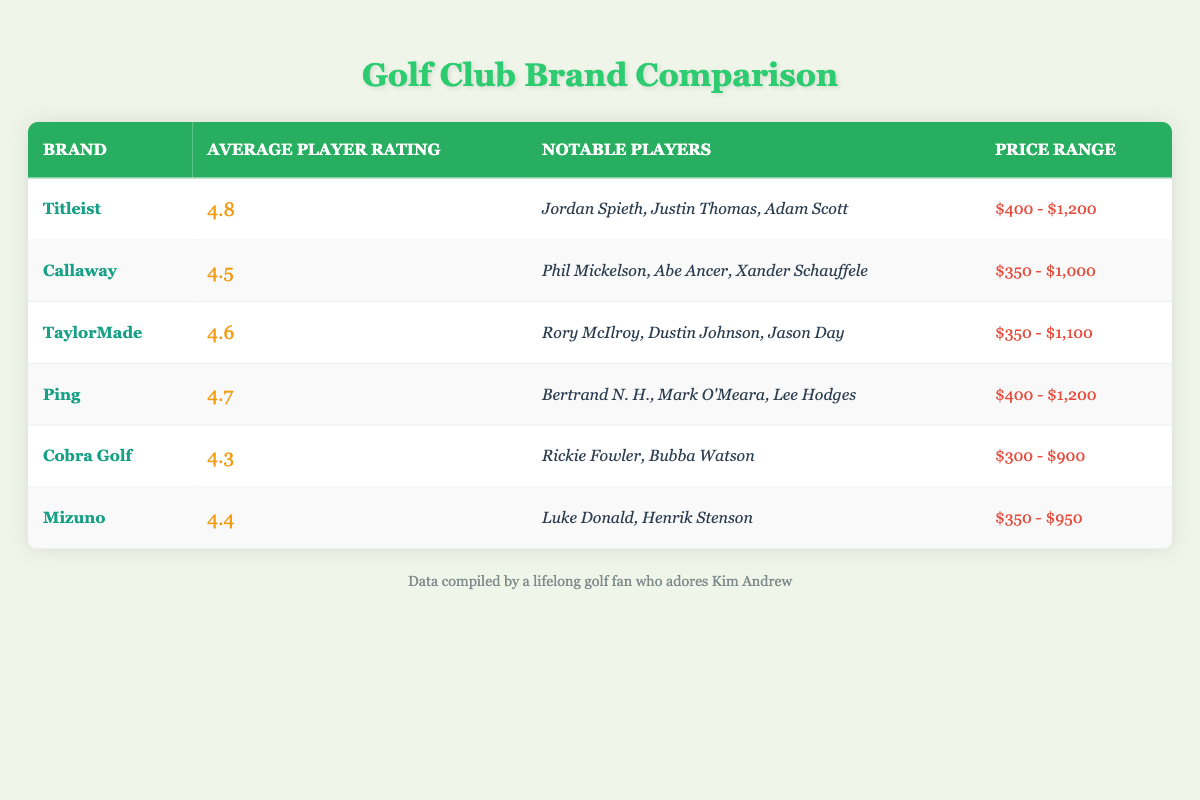What is the average player rating of Titleist? Titleist has an average player rating listed in the table. That rating is found in the row corresponding to Titleist, where it's mentioned clearly as 4.8.
Answer: 4.8 Which brand has the highest average player rating? By comparing the average player ratings listed for each brand, Titleist has the highest rating at 4.8, followed by Ping at 4.7.
Answer: Titleist Is the price range for Callaway clubs lower than that for Cobra Golf clubs? The price range for Callaway is from $350 to $1,000, while for Cobra Golf it's $300 to $900. Since $1,000 is higher than $900, the price range for Callaway is not lower than Cobra Golf's range.
Answer: No How many notable players are associated with TaylorMade? Looking at the row for TaylorMade, it lists three notable players: Rory McIlroy, Dustin Johnson, and Jason Day. Therefore, the count of notable players is three.
Answer: 3 What is the difference in average player ratings between Ping and Mizuno? The average player rating for Ping is 4.7, and for Mizuno, it is 4.4. To find the difference, subtract Mizuno's rating from Ping's: 4.7 - 4.4 = 0.3.
Answer: 0.3 Are there more notable players listed for Cobra Golf than for Mizuno? The notable players for Cobra Golf are Rickie Fowler and Bubba Watson, totaling two. For Mizuno, there are also two notable players: Luke Donald and Henrik Stenson. Since both brands have the same number (two), there are not more notable players for Cobra Golf than Mizuno.
Answer: No What is the average of the average player ratings for all brands? To find the average, sum all average ratings: (4.8 + 4.5 + 4.6 + 4.7 + 4.3 + 4.4) = 27.3. Then, divide by the number of brands, which is 6: 27.3 / 6 = 4.55.
Answer: 4.55 Which brand has a price range that overlaps with both Titleist and Ping? Titleist and Ping have a price range from $400 to $1,200. Callaway's range is $350 to $1,000, but only Titleist and Ping have the same overlap. Therefore, the answer is none, since Cobra Golf and Mizuno do not overlap as well.
Answer: None What is the average player rating for all brands that have a price range exceeding $1,000? The brands with a price range exceeding $1,000 are Titleist and Ping. Their average ratings are 4.8 and 4.7, respectively. To calculate the average: (4.8 + 4.7) / 2 = 4.75.
Answer: 4.75 